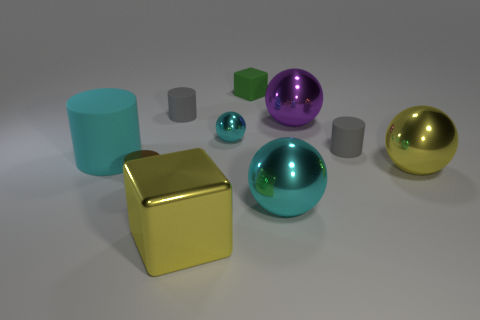Subtract all yellow metal balls. How many balls are left? 3 Subtract all brown blocks. How many gray cylinders are left? 2 Subtract all purple balls. How many balls are left? 3 Subtract all blocks. How many objects are left? 8 Subtract 0 red blocks. How many objects are left? 10 Subtract 2 spheres. How many spheres are left? 2 Subtract all brown blocks. Subtract all brown cylinders. How many blocks are left? 2 Subtract all small rubber blocks. Subtract all metallic blocks. How many objects are left? 8 Add 7 small spheres. How many small spheres are left? 8 Add 6 big brown rubber spheres. How many big brown rubber spheres exist? 6 